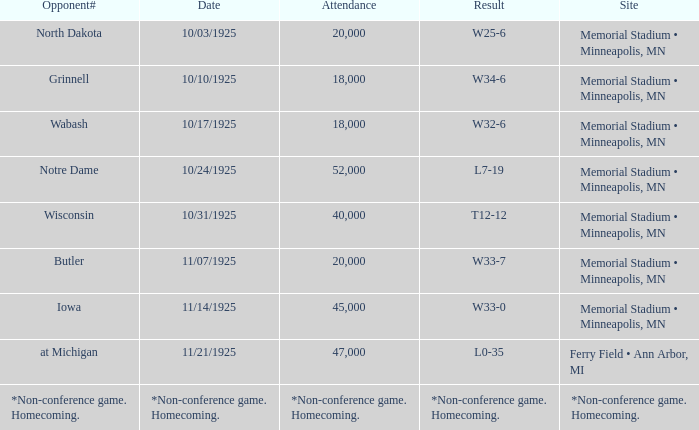Who was the opponent at the game attended by 45,000? Iowa. 